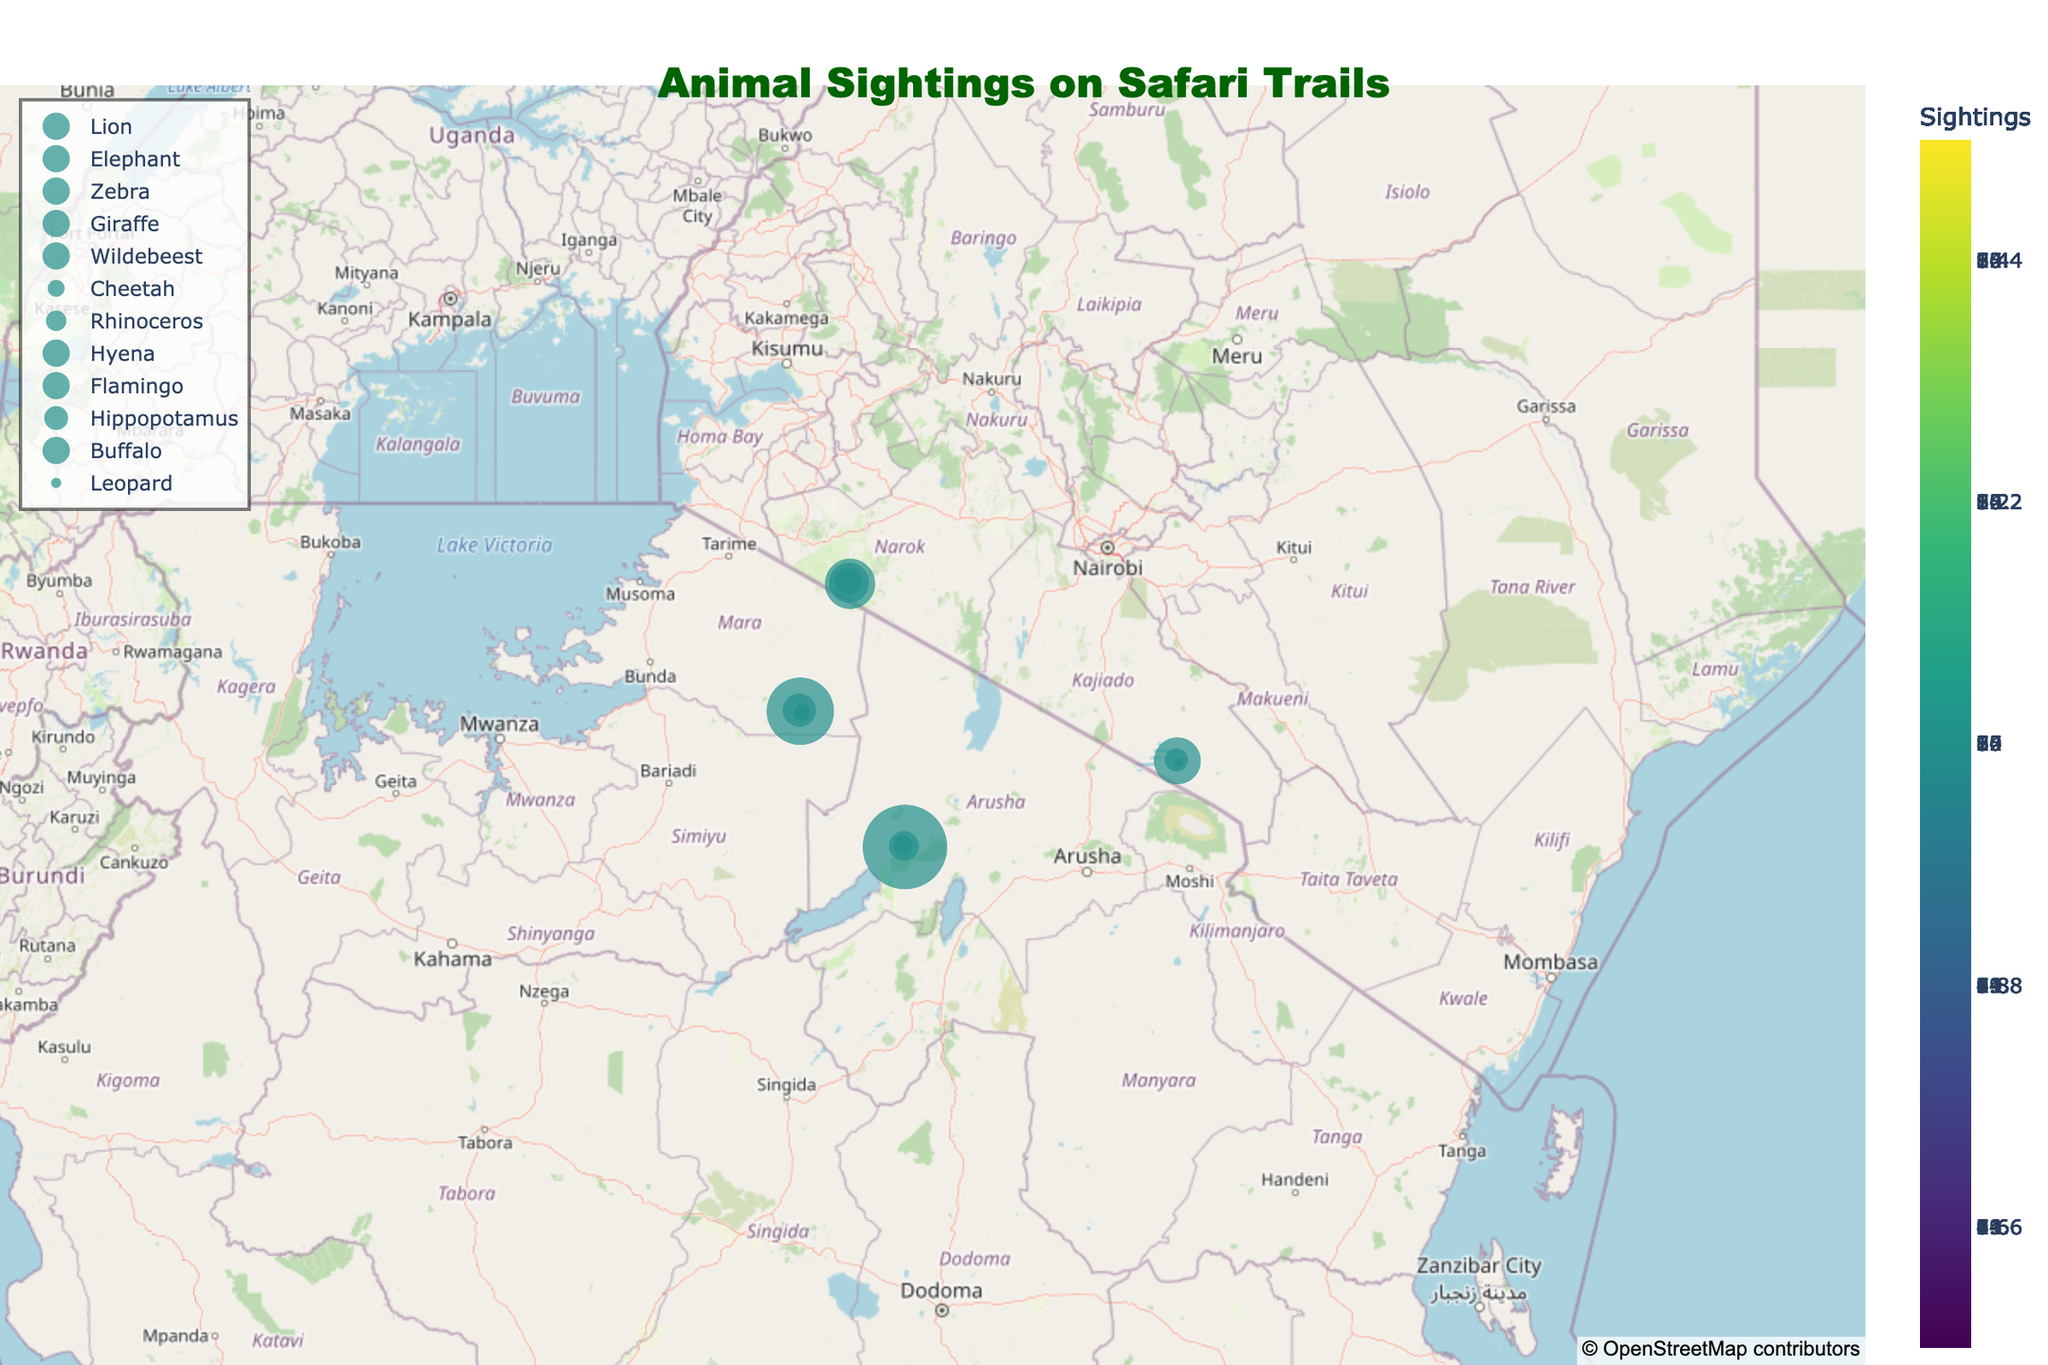Which safari trail has the highest number of zebra sightings in the evening? The zebra sightings only appeared on the Masai Mara River Trail in the evening with 15 sightings according to the plot.
Answer: Masai Mara River Trail How many species are sighted in the Serengeti Plains Route during the morning? The plot shows 10 giraffe sightings in the Serengeti Plains Route during the morning.
Answer: 1 Which species has the highest number of sightings on the Ngorongoro Crater Path in the evening? The plot indicates Flamingo has the highest sightings in the evening on the Ngorongoro Crater Path with 25 sightings.
Answer: Flamingo What's the total number of animal sightings on the Amboseli Wetlands Track? Summing up the sightings on the Amboseli Wetlands Track: 7 (Hippopotamus, Morning) + 14 (Buffalo, Afternoon) + 3 (Leopard, Evening) gives 24 sightings.
Answer: 24 Which species appears most frequently on the Serengeti Plains Route during the afternoon? The plot shows wildebeest as the species with the highest number of sightings (20) in the afternoon on the Serengeti Plains Route.
Answer: Wildebeest How do the lion sightings on the Masai Mara River Trail in the morning compare to the rhinoceros sightings on the Ngorongoro Crater Path in the morning? Comparing the sightings, lions on the Masai Mara River Trail morning have 8 sightings while rhinoceroses on the Ngorongoro Crater Path morning have 6 sightings.
Answer: Lion sightings are more Which trail has the most diversified species sightings overall? Ngorongoro Crater Path and Amboseli Wetlands Track both show three different species, but Ngorongoro Crater Path has a higher total number of sightings.
Answer: Ngorongoro Crater Path What's the latitude and longitude of the morning hippo sightings on the Amboseli Wetlands Track? The latitude and longitude for Hippopotamus sightings in the morning on Amboseli Wetlands Track are shown as -2.6527 and 37.2606 respectively.
Answer: -2.6527, 37.2606 Comparing evening sightings, which trail has the highest number of animal sightings? According to the plot, the Ngorongoro Crater Path has the highest animal sightings during the evening with a total of 25 sightings (Flamingo).
Answer: Ngorongoro Crater Path 